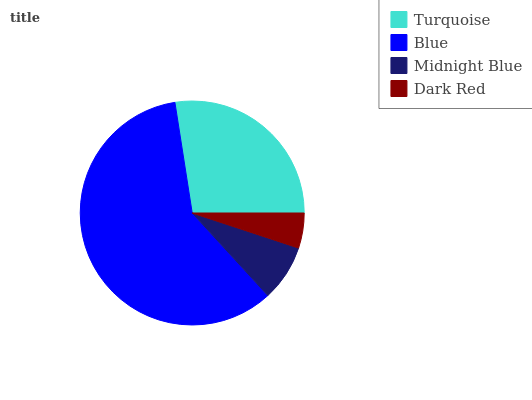Is Dark Red the minimum?
Answer yes or no. Yes. Is Blue the maximum?
Answer yes or no. Yes. Is Midnight Blue the minimum?
Answer yes or no. No. Is Midnight Blue the maximum?
Answer yes or no. No. Is Blue greater than Midnight Blue?
Answer yes or no. Yes. Is Midnight Blue less than Blue?
Answer yes or no. Yes. Is Midnight Blue greater than Blue?
Answer yes or no. No. Is Blue less than Midnight Blue?
Answer yes or no. No. Is Turquoise the high median?
Answer yes or no. Yes. Is Midnight Blue the low median?
Answer yes or no. Yes. Is Dark Red the high median?
Answer yes or no. No. Is Blue the low median?
Answer yes or no. No. 